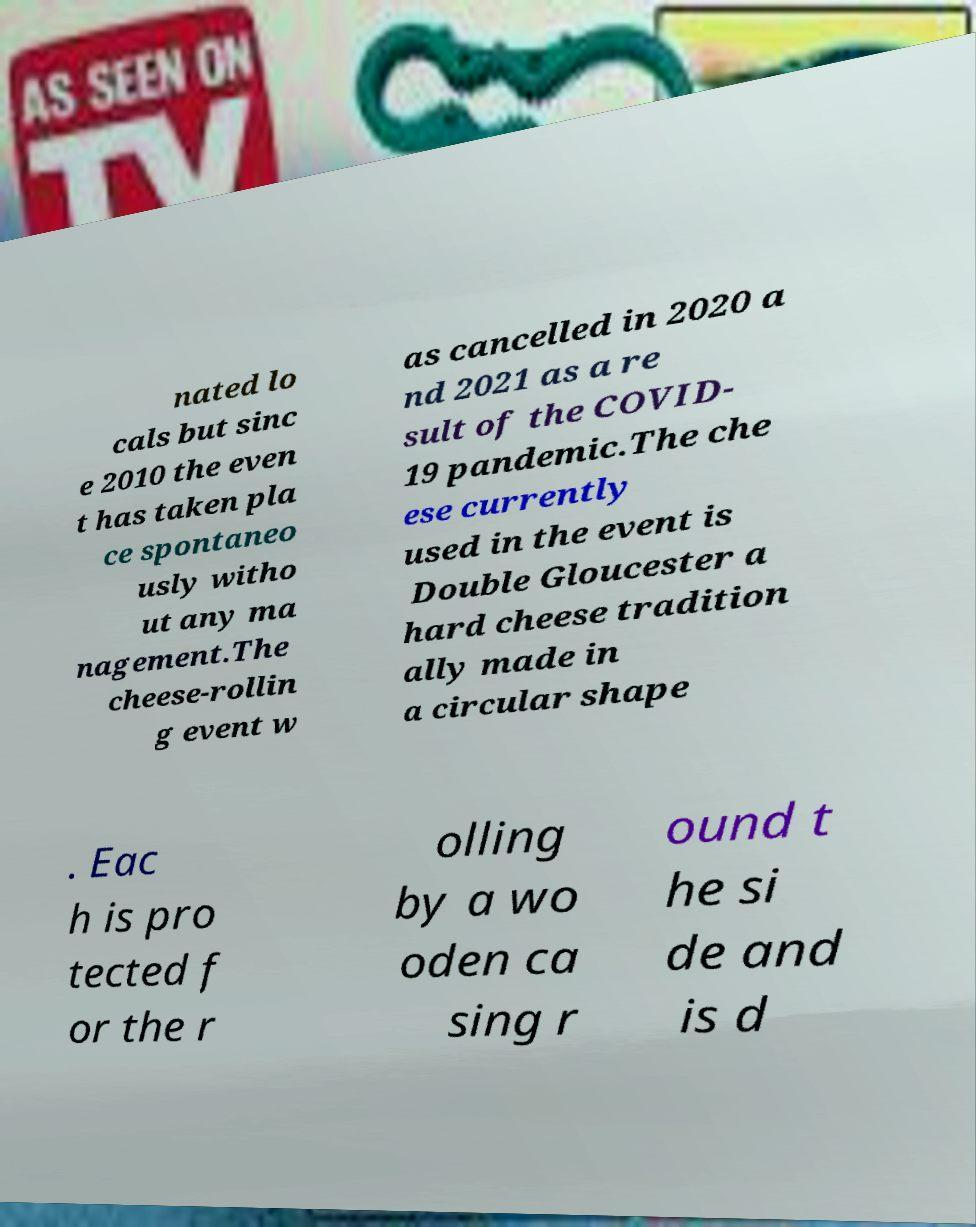Please read and relay the text visible in this image. What does it say? nated lo cals but sinc e 2010 the even t has taken pla ce spontaneo usly witho ut any ma nagement.The cheese-rollin g event w as cancelled in 2020 a nd 2021 as a re sult of the COVID- 19 pandemic.The che ese currently used in the event is Double Gloucester a hard cheese tradition ally made in a circular shape . Eac h is pro tected f or the r olling by a wo oden ca sing r ound t he si de and is d 